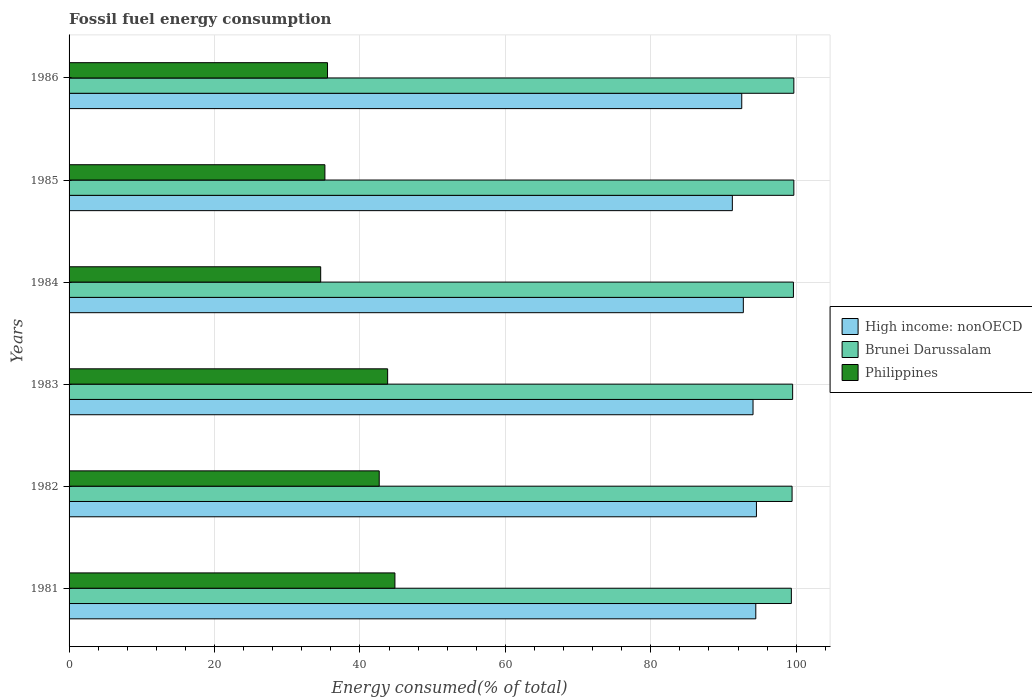How many different coloured bars are there?
Your response must be concise. 3. Are the number of bars per tick equal to the number of legend labels?
Your answer should be compact. Yes. How many bars are there on the 4th tick from the top?
Your answer should be compact. 3. In how many cases, is the number of bars for a given year not equal to the number of legend labels?
Provide a succinct answer. 0. What is the percentage of energy consumed in High income: nonOECD in 1983?
Ensure brevity in your answer.  94.06. Across all years, what is the maximum percentage of energy consumed in High income: nonOECD?
Give a very brief answer. 94.53. Across all years, what is the minimum percentage of energy consumed in Philippines?
Your answer should be compact. 34.6. In which year was the percentage of energy consumed in Brunei Darussalam minimum?
Your answer should be very brief. 1981. What is the total percentage of energy consumed in Philippines in the graph?
Offer a terse response. 236.6. What is the difference between the percentage of energy consumed in Philippines in 1981 and that in 1984?
Provide a succinct answer. 10.21. What is the difference between the percentage of energy consumed in Brunei Darussalam in 1985 and the percentage of energy consumed in Philippines in 1982?
Keep it short and to the point. 57.02. What is the average percentage of energy consumed in Brunei Darussalam per year?
Your answer should be very brief. 99.54. In the year 1983, what is the difference between the percentage of energy consumed in Philippines and percentage of energy consumed in Brunei Darussalam?
Offer a terse response. -55.7. In how many years, is the percentage of energy consumed in High income: nonOECD greater than 28 %?
Ensure brevity in your answer.  6. What is the ratio of the percentage of energy consumed in High income: nonOECD in 1982 to that in 1985?
Ensure brevity in your answer.  1.04. Is the percentage of energy consumed in Brunei Darussalam in 1981 less than that in 1984?
Make the answer very short. Yes. Is the difference between the percentage of energy consumed in Philippines in 1981 and 1984 greater than the difference between the percentage of energy consumed in Brunei Darussalam in 1981 and 1984?
Provide a short and direct response. Yes. What is the difference between the highest and the second highest percentage of energy consumed in Brunei Darussalam?
Keep it short and to the point. 0. What is the difference between the highest and the lowest percentage of energy consumed in High income: nonOECD?
Offer a terse response. 3.31. Is the sum of the percentage of energy consumed in High income: nonOECD in 1981 and 1982 greater than the maximum percentage of energy consumed in Philippines across all years?
Your answer should be compact. Yes. What does the 3rd bar from the top in 1984 represents?
Your response must be concise. High income: nonOECD. What does the 1st bar from the bottom in 1985 represents?
Offer a very short reply. High income: nonOECD. Are all the bars in the graph horizontal?
Your answer should be very brief. Yes. How many years are there in the graph?
Your answer should be compact. 6. What is the difference between two consecutive major ticks on the X-axis?
Offer a terse response. 20. Are the values on the major ticks of X-axis written in scientific E-notation?
Make the answer very short. No. Does the graph contain grids?
Provide a succinct answer. Yes. Where does the legend appear in the graph?
Your answer should be compact. Center right. How many legend labels are there?
Offer a very short reply. 3. How are the legend labels stacked?
Give a very brief answer. Vertical. What is the title of the graph?
Provide a succinct answer. Fossil fuel energy consumption. What is the label or title of the X-axis?
Offer a terse response. Energy consumed(% of total). What is the label or title of the Y-axis?
Offer a terse response. Years. What is the Energy consumed(% of total) in High income: nonOECD in 1981?
Provide a succinct answer. 94.44. What is the Energy consumed(% of total) in Brunei Darussalam in 1981?
Make the answer very short. 99.33. What is the Energy consumed(% of total) in Philippines in 1981?
Provide a succinct answer. 44.81. What is the Energy consumed(% of total) of High income: nonOECD in 1982?
Your response must be concise. 94.53. What is the Energy consumed(% of total) in Brunei Darussalam in 1982?
Keep it short and to the point. 99.43. What is the Energy consumed(% of total) of Philippines in 1982?
Provide a short and direct response. 42.65. What is the Energy consumed(% of total) of High income: nonOECD in 1983?
Provide a succinct answer. 94.06. What is the Energy consumed(% of total) in Brunei Darussalam in 1983?
Provide a short and direct response. 99.51. What is the Energy consumed(% of total) in Philippines in 1983?
Offer a terse response. 43.81. What is the Energy consumed(% of total) of High income: nonOECD in 1984?
Offer a terse response. 92.73. What is the Energy consumed(% of total) in Brunei Darussalam in 1984?
Ensure brevity in your answer.  99.62. What is the Energy consumed(% of total) of Philippines in 1984?
Give a very brief answer. 34.6. What is the Energy consumed(% of total) of High income: nonOECD in 1985?
Make the answer very short. 91.21. What is the Energy consumed(% of total) of Brunei Darussalam in 1985?
Offer a very short reply. 99.67. What is the Energy consumed(% of total) in Philippines in 1985?
Give a very brief answer. 35.18. What is the Energy consumed(% of total) in High income: nonOECD in 1986?
Your answer should be compact. 92.51. What is the Energy consumed(% of total) of Brunei Darussalam in 1986?
Provide a succinct answer. 99.67. What is the Energy consumed(% of total) in Philippines in 1986?
Your answer should be compact. 35.54. Across all years, what is the maximum Energy consumed(% of total) of High income: nonOECD?
Your response must be concise. 94.53. Across all years, what is the maximum Energy consumed(% of total) in Brunei Darussalam?
Provide a succinct answer. 99.67. Across all years, what is the maximum Energy consumed(% of total) of Philippines?
Your answer should be compact. 44.81. Across all years, what is the minimum Energy consumed(% of total) of High income: nonOECD?
Keep it short and to the point. 91.21. Across all years, what is the minimum Energy consumed(% of total) in Brunei Darussalam?
Provide a short and direct response. 99.33. Across all years, what is the minimum Energy consumed(% of total) in Philippines?
Make the answer very short. 34.6. What is the total Energy consumed(% of total) in High income: nonOECD in the graph?
Offer a terse response. 559.48. What is the total Energy consumed(% of total) in Brunei Darussalam in the graph?
Keep it short and to the point. 597.23. What is the total Energy consumed(% of total) in Philippines in the graph?
Ensure brevity in your answer.  236.6. What is the difference between the Energy consumed(% of total) in High income: nonOECD in 1981 and that in 1982?
Give a very brief answer. -0.09. What is the difference between the Energy consumed(% of total) of Brunei Darussalam in 1981 and that in 1982?
Make the answer very short. -0.1. What is the difference between the Energy consumed(% of total) in Philippines in 1981 and that in 1982?
Offer a terse response. 2.16. What is the difference between the Energy consumed(% of total) of High income: nonOECD in 1981 and that in 1983?
Give a very brief answer. 0.38. What is the difference between the Energy consumed(% of total) in Brunei Darussalam in 1981 and that in 1983?
Provide a succinct answer. -0.18. What is the difference between the Energy consumed(% of total) in High income: nonOECD in 1981 and that in 1984?
Ensure brevity in your answer.  1.71. What is the difference between the Energy consumed(% of total) in Brunei Darussalam in 1981 and that in 1984?
Your answer should be compact. -0.28. What is the difference between the Energy consumed(% of total) of Philippines in 1981 and that in 1984?
Your answer should be compact. 10.21. What is the difference between the Energy consumed(% of total) in High income: nonOECD in 1981 and that in 1985?
Make the answer very short. 3.22. What is the difference between the Energy consumed(% of total) in Brunei Darussalam in 1981 and that in 1985?
Offer a terse response. -0.34. What is the difference between the Energy consumed(% of total) in Philippines in 1981 and that in 1985?
Keep it short and to the point. 9.63. What is the difference between the Energy consumed(% of total) of High income: nonOECD in 1981 and that in 1986?
Offer a terse response. 1.93. What is the difference between the Energy consumed(% of total) in Brunei Darussalam in 1981 and that in 1986?
Keep it short and to the point. -0.34. What is the difference between the Energy consumed(% of total) in Philippines in 1981 and that in 1986?
Offer a very short reply. 9.27. What is the difference between the Energy consumed(% of total) of High income: nonOECD in 1982 and that in 1983?
Your answer should be very brief. 0.47. What is the difference between the Energy consumed(% of total) of Brunei Darussalam in 1982 and that in 1983?
Your answer should be very brief. -0.08. What is the difference between the Energy consumed(% of total) of Philippines in 1982 and that in 1983?
Offer a very short reply. -1.16. What is the difference between the Energy consumed(% of total) in High income: nonOECD in 1982 and that in 1984?
Your answer should be very brief. 1.8. What is the difference between the Energy consumed(% of total) of Brunei Darussalam in 1982 and that in 1984?
Give a very brief answer. -0.19. What is the difference between the Energy consumed(% of total) in Philippines in 1982 and that in 1984?
Make the answer very short. 8.05. What is the difference between the Energy consumed(% of total) of High income: nonOECD in 1982 and that in 1985?
Offer a very short reply. 3.31. What is the difference between the Energy consumed(% of total) of Brunei Darussalam in 1982 and that in 1985?
Provide a succinct answer. -0.24. What is the difference between the Energy consumed(% of total) of Philippines in 1982 and that in 1985?
Offer a very short reply. 7.47. What is the difference between the Energy consumed(% of total) in High income: nonOECD in 1982 and that in 1986?
Your answer should be very brief. 2.02. What is the difference between the Energy consumed(% of total) in Brunei Darussalam in 1982 and that in 1986?
Offer a terse response. -0.24. What is the difference between the Energy consumed(% of total) of Philippines in 1982 and that in 1986?
Give a very brief answer. 7.11. What is the difference between the Energy consumed(% of total) of High income: nonOECD in 1983 and that in 1984?
Your answer should be very brief. 1.34. What is the difference between the Energy consumed(% of total) in Brunei Darussalam in 1983 and that in 1984?
Ensure brevity in your answer.  -0.11. What is the difference between the Energy consumed(% of total) in Philippines in 1983 and that in 1984?
Ensure brevity in your answer.  9.21. What is the difference between the Energy consumed(% of total) of High income: nonOECD in 1983 and that in 1985?
Offer a very short reply. 2.85. What is the difference between the Energy consumed(% of total) of Brunei Darussalam in 1983 and that in 1985?
Keep it short and to the point. -0.17. What is the difference between the Energy consumed(% of total) in Philippines in 1983 and that in 1985?
Your answer should be compact. 8.63. What is the difference between the Energy consumed(% of total) in High income: nonOECD in 1983 and that in 1986?
Provide a succinct answer. 1.55. What is the difference between the Energy consumed(% of total) of Brunei Darussalam in 1983 and that in 1986?
Give a very brief answer. -0.17. What is the difference between the Energy consumed(% of total) in Philippines in 1983 and that in 1986?
Ensure brevity in your answer.  8.27. What is the difference between the Energy consumed(% of total) in High income: nonOECD in 1984 and that in 1985?
Give a very brief answer. 1.51. What is the difference between the Energy consumed(% of total) of Brunei Darussalam in 1984 and that in 1985?
Your answer should be compact. -0.06. What is the difference between the Energy consumed(% of total) in Philippines in 1984 and that in 1985?
Keep it short and to the point. -0.58. What is the difference between the Energy consumed(% of total) in High income: nonOECD in 1984 and that in 1986?
Your answer should be compact. 0.22. What is the difference between the Energy consumed(% of total) of Brunei Darussalam in 1984 and that in 1986?
Your response must be concise. -0.06. What is the difference between the Energy consumed(% of total) in Philippines in 1984 and that in 1986?
Make the answer very short. -0.94. What is the difference between the Energy consumed(% of total) in High income: nonOECD in 1985 and that in 1986?
Provide a short and direct response. -1.29. What is the difference between the Energy consumed(% of total) in Brunei Darussalam in 1985 and that in 1986?
Make the answer very short. -0. What is the difference between the Energy consumed(% of total) in Philippines in 1985 and that in 1986?
Your response must be concise. -0.36. What is the difference between the Energy consumed(% of total) of High income: nonOECD in 1981 and the Energy consumed(% of total) of Brunei Darussalam in 1982?
Offer a terse response. -4.99. What is the difference between the Energy consumed(% of total) in High income: nonOECD in 1981 and the Energy consumed(% of total) in Philippines in 1982?
Your answer should be compact. 51.79. What is the difference between the Energy consumed(% of total) in Brunei Darussalam in 1981 and the Energy consumed(% of total) in Philippines in 1982?
Keep it short and to the point. 56.68. What is the difference between the Energy consumed(% of total) of High income: nonOECD in 1981 and the Energy consumed(% of total) of Brunei Darussalam in 1983?
Offer a terse response. -5.07. What is the difference between the Energy consumed(% of total) in High income: nonOECD in 1981 and the Energy consumed(% of total) in Philippines in 1983?
Your response must be concise. 50.63. What is the difference between the Energy consumed(% of total) of Brunei Darussalam in 1981 and the Energy consumed(% of total) of Philippines in 1983?
Your response must be concise. 55.52. What is the difference between the Energy consumed(% of total) in High income: nonOECD in 1981 and the Energy consumed(% of total) in Brunei Darussalam in 1984?
Offer a very short reply. -5.18. What is the difference between the Energy consumed(% of total) in High income: nonOECD in 1981 and the Energy consumed(% of total) in Philippines in 1984?
Your answer should be very brief. 59.84. What is the difference between the Energy consumed(% of total) in Brunei Darussalam in 1981 and the Energy consumed(% of total) in Philippines in 1984?
Your answer should be compact. 64.73. What is the difference between the Energy consumed(% of total) in High income: nonOECD in 1981 and the Energy consumed(% of total) in Brunei Darussalam in 1985?
Ensure brevity in your answer.  -5.23. What is the difference between the Energy consumed(% of total) in High income: nonOECD in 1981 and the Energy consumed(% of total) in Philippines in 1985?
Provide a short and direct response. 59.26. What is the difference between the Energy consumed(% of total) in Brunei Darussalam in 1981 and the Energy consumed(% of total) in Philippines in 1985?
Your answer should be very brief. 64.15. What is the difference between the Energy consumed(% of total) in High income: nonOECD in 1981 and the Energy consumed(% of total) in Brunei Darussalam in 1986?
Offer a very short reply. -5.23. What is the difference between the Energy consumed(% of total) of High income: nonOECD in 1981 and the Energy consumed(% of total) of Philippines in 1986?
Give a very brief answer. 58.9. What is the difference between the Energy consumed(% of total) of Brunei Darussalam in 1981 and the Energy consumed(% of total) of Philippines in 1986?
Offer a very short reply. 63.79. What is the difference between the Energy consumed(% of total) in High income: nonOECD in 1982 and the Energy consumed(% of total) in Brunei Darussalam in 1983?
Ensure brevity in your answer.  -4.98. What is the difference between the Energy consumed(% of total) in High income: nonOECD in 1982 and the Energy consumed(% of total) in Philippines in 1983?
Make the answer very short. 50.72. What is the difference between the Energy consumed(% of total) of Brunei Darussalam in 1982 and the Energy consumed(% of total) of Philippines in 1983?
Offer a terse response. 55.62. What is the difference between the Energy consumed(% of total) in High income: nonOECD in 1982 and the Energy consumed(% of total) in Brunei Darussalam in 1984?
Give a very brief answer. -5.09. What is the difference between the Energy consumed(% of total) in High income: nonOECD in 1982 and the Energy consumed(% of total) in Philippines in 1984?
Offer a very short reply. 59.93. What is the difference between the Energy consumed(% of total) of Brunei Darussalam in 1982 and the Energy consumed(% of total) of Philippines in 1984?
Your response must be concise. 64.83. What is the difference between the Energy consumed(% of total) of High income: nonOECD in 1982 and the Energy consumed(% of total) of Brunei Darussalam in 1985?
Offer a terse response. -5.14. What is the difference between the Energy consumed(% of total) in High income: nonOECD in 1982 and the Energy consumed(% of total) in Philippines in 1985?
Keep it short and to the point. 59.35. What is the difference between the Energy consumed(% of total) in Brunei Darussalam in 1982 and the Energy consumed(% of total) in Philippines in 1985?
Provide a short and direct response. 64.25. What is the difference between the Energy consumed(% of total) of High income: nonOECD in 1982 and the Energy consumed(% of total) of Brunei Darussalam in 1986?
Make the answer very short. -5.14. What is the difference between the Energy consumed(% of total) in High income: nonOECD in 1982 and the Energy consumed(% of total) in Philippines in 1986?
Provide a succinct answer. 58.99. What is the difference between the Energy consumed(% of total) of Brunei Darussalam in 1982 and the Energy consumed(% of total) of Philippines in 1986?
Offer a terse response. 63.89. What is the difference between the Energy consumed(% of total) in High income: nonOECD in 1983 and the Energy consumed(% of total) in Brunei Darussalam in 1984?
Offer a terse response. -5.55. What is the difference between the Energy consumed(% of total) of High income: nonOECD in 1983 and the Energy consumed(% of total) of Philippines in 1984?
Offer a very short reply. 59.46. What is the difference between the Energy consumed(% of total) of Brunei Darussalam in 1983 and the Energy consumed(% of total) of Philippines in 1984?
Give a very brief answer. 64.91. What is the difference between the Energy consumed(% of total) in High income: nonOECD in 1983 and the Energy consumed(% of total) in Brunei Darussalam in 1985?
Provide a short and direct response. -5.61. What is the difference between the Energy consumed(% of total) of High income: nonOECD in 1983 and the Energy consumed(% of total) of Philippines in 1985?
Your response must be concise. 58.88. What is the difference between the Energy consumed(% of total) of Brunei Darussalam in 1983 and the Energy consumed(% of total) of Philippines in 1985?
Offer a terse response. 64.33. What is the difference between the Energy consumed(% of total) of High income: nonOECD in 1983 and the Energy consumed(% of total) of Brunei Darussalam in 1986?
Your answer should be very brief. -5.61. What is the difference between the Energy consumed(% of total) of High income: nonOECD in 1983 and the Energy consumed(% of total) of Philippines in 1986?
Provide a succinct answer. 58.52. What is the difference between the Energy consumed(% of total) of Brunei Darussalam in 1983 and the Energy consumed(% of total) of Philippines in 1986?
Your answer should be very brief. 63.97. What is the difference between the Energy consumed(% of total) of High income: nonOECD in 1984 and the Energy consumed(% of total) of Brunei Darussalam in 1985?
Your response must be concise. -6.95. What is the difference between the Energy consumed(% of total) in High income: nonOECD in 1984 and the Energy consumed(% of total) in Philippines in 1985?
Your answer should be very brief. 57.54. What is the difference between the Energy consumed(% of total) in Brunei Darussalam in 1984 and the Energy consumed(% of total) in Philippines in 1985?
Your answer should be compact. 64.43. What is the difference between the Energy consumed(% of total) in High income: nonOECD in 1984 and the Energy consumed(% of total) in Brunei Darussalam in 1986?
Provide a short and direct response. -6.95. What is the difference between the Energy consumed(% of total) in High income: nonOECD in 1984 and the Energy consumed(% of total) in Philippines in 1986?
Offer a very short reply. 57.18. What is the difference between the Energy consumed(% of total) in Brunei Darussalam in 1984 and the Energy consumed(% of total) in Philippines in 1986?
Offer a very short reply. 64.07. What is the difference between the Energy consumed(% of total) of High income: nonOECD in 1985 and the Energy consumed(% of total) of Brunei Darussalam in 1986?
Keep it short and to the point. -8.46. What is the difference between the Energy consumed(% of total) in High income: nonOECD in 1985 and the Energy consumed(% of total) in Philippines in 1986?
Offer a very short reply. 55.67. What is the difference between the Energy consumed(% of total) of Brunei Darussalam in 1985 and the Energy consumed(% of total) of Philippines in 1986?
Keep it short and to the point. 64.13. What is the average Energy consumed(% of total) of High income: nonOECD per year?
Provide a succinct answer. 93.25. What is the average Energy consumed(% of total) of Brunei Darussalam per year?
Provide a succinct answer. 99.54. What is the average Energy consumed(% of total) of Philippines per year?
Provide a short and direct response. 39.43. In the year 1981, what is the difference between the Energy consumed(% of total) of High income: nonOECD and Energy consumed(% of total) of Brunei Darussalam?
Keep it short and to the point. -4.89. In the year 1981, what is the difference between the Energy consumed(% of total) of High income: nonOECD and Energy consumed(% of total) of Philippines?
Your answer should be very brief. 49.63. In the year 1981, what is the difference between the Energy consumed(% of total) of Brunei Darussalam and Energy consumed(% of total) of Philippines?
Offer a terse response. 54.52. In the year 1982, what is the difference between the Energy consumed(% of total) of High income: nonOECD and Energy consumed(% of total) of Brunei Darussalam?
Provide a short and direct response. -4.9. In the year 1982, what is the difference between the Energy consumed(% of total) of High income: nonOECD and Energy consumed(% of total) of Philippines?
Ensure brevity in your answer.  51.88. In the year 1982, what is the difference between the Energy consumed(% of total) of Brunei Darussalam and Energy consumed(% of total) of Philippines?
Your answer should be compact. 56.78. In the year 1983, what is the difference between the Energy consumed(% of total) in High income: nonOECD and Energy consumed(% of total) in Brunei Darussalam?
Give a very brief answer. -5.45. In the year 1983, what is the difference between the Energy consumed(% of total) in High income: nonOECD and Energy consumed(% of total) in Philippines?
Make the answer very short. 50.25. In the year 1983, what is the difference between the Energy consumed(% of total) of Brunei Darussalam and Energy consumed(% of total) of Philippines?
Provide a short and direct response. 55.7. In the year 1984, what is the difference between the Energy consumed(% of total) in High income: nonOECD and Energy consumed(% of total) in Brunei Darussalam?
Provide a succinct answer. -6.89. In the year 1984, what is the difference between the Energy consumed(% of total) of High income: nonOECD and Energy consumed(% of total) of Philippines?
Provide a succinct answer. 58.12. In the year 1984, what is the difference between the Energy consumed(% of total) of Brunei Darussalam and Energy consumed(% of total) of Philippines?
Your answer should be very brief. 65.01. In the year 1985, what is the difference between the Energy consumed(% of total) in High income: nonOECD and Energy consumed(% of total) in Brunei Darussalam?
Offer a terse response. -8.46. In the year 1985, what is the difference between the Energy consumed(% of total) in High income: nonOECD and Energy consumed(% of total) in Philippines?
Your answer should be compact. 56.03. In the year 1985, what is the difference between the Energy consumed(% of total) of Brunei Darussalam and Energy consumed(% of total) of Philippines?
Offer a very short reply. 64.49. In the year 1986, what is the difference between the Energy consumed(% of total) of High income: nonOECD and Energy consumed(% of total) of Brunei Darussalam?
Provide a succinct answer. -7.16. In the year 1986, what is the difference between the Energy consumed(% of total) in High income: nonOECD and Energy consumed(% of total) in Philippines?
Your answer should be very brief. 56.97. In the year 1986, what is the difference between the Energy consumed(% of total) of Brunei Darussalam and Energy consumed(% of total) of Philippines?
Give a very brief answer. 64.13. What is the ratio of the Energy consumed(% of total) in Philippines in 1981 to that in 1982?
Keep it short and to the point. 1.05. What is the ratio of the Energy consumed(% of total) in High income: nonOECD in 1981 to that in 1983?
Provide a short and direct response. 1. What is the ratio of the Energy consumed(% of total) in Brunei Darussalam in 1981 to that in 1983?
Your answer should be very brief. 1. What is the ratio of the Energy consumed(% of total) in Philippines in 1981 to that in 1983?
Ensure brevity in your answer.  1.02. What is the ratio of the Energy consumed(% of total) in High income: nonOECD in 1981 to that in 1984?
Your answer should be compact. 1.02. What is the ratio of the Energy consumed(% of total) of Philippines in 1981 to that in 1984?
Offer a very short reply. 1.29. What is the ratio of the Energy consumed(% of total) of High income: nonOECD in 1981 to that in 1985?
Your response must be concise. 1.04. What is the ratio of the Energy consumed(% of total) of Brunei Darussalam in 1981 to that in 1985?
Your answer should be very brief. 1. What is the ratio of the Energy consumed(% of total) in Philippines in 1981 to that in 1985?
Give a very brief answer. 1.27. What is the ratio of the Energy consumed(% of total) of High income: nonOECD in 1981 to that in 1986?
Your answer should be compact. 1.02. What is the ratio of the Energy consumed(% of total) in Brunei Darussalam in 1981 to that in 1986?
Offer a very short reply. 1. What is the ratio of the Energy consumed(% of total) of Philippines in 1981 to that in 1986?
Provide a succinct answer. 1.26. What is the ratio of the Energy consumed(% of total) in High income: nonOECD in 1982 to that in 1983?
Give a very brief answer. 1. What is the ratio of the Energy consumed(% of total) of Philippines in 1982 to that in 1983?
Your answer should be compact. 0.97. What is the ratio of the Energy consumed(% of total) of High income: nonOECD in 1982 to that in 1984?
Your response must be concise. 1.02. What is the ratio of the Energy consumed(% of total) of Philippines in 1982 to that in 1984?
Your answer should be very brief. 1.23. What is the ratio of the Energy consumed(% of total) in High income: nonOECD in 1982 to that in 1985?
Offer a very short reply. 1.04. What is the ratio of the Energy consumed(% of total) in Philippines in 1982 to that in 1985?
Provide a succinct answer. 1.21. What is the ratio of the Energy consumed(% of total) in High income: nonOECD in 1982 to that in 1986?
Provide a succinct answer. 1.02. What is the ratio of the Energy consumed(% of total) of Brunei Darussalam in 1982 to that in 1986?
Your response must be concise. 1. What is the ratio of the Energy consumed(% of total) of Philippines in 1982 to that in 1986?
Offer a very short reply. 1.2. What is the ratio of the Energy consumed(% of total) of High income: nonOECD in 1983 to that in 1984?
Give a very brief answer. 1.01. What is the ratio of the Energy consumed(% of total) in Philippines in 1983 to that in 1984?
Your answer should be compact. 1.27. What is the ratio of the Energy consumed(% of total) in High income: nonOECD in 1983 to that in 1985?
Your answer should be very brief. 1.03. What is the ratio of the Energy consumed(% of total) in Brunei Darussalam in 1983 to that in 1985?
Offer a very short reply. 1. What is the ratio of the Energy consumed(% of total) in Philippines in 1983 to that in 1985?
Ensure brevity in your answer.  1.25. What is the ratio of the Energy consumed(% of total) of High income: nonOECD in 1983 to that in 1986?
Provide a succinct answer. 1.02. What is the ratio of the Energy consumed(% of total) in Brunei Darussalam in 1983 to that in 1986?
Give a very brief answer. 1. What is the ratio of the Energy consumed(% of total) of Philippines in 1983 to that in 1986?
Ensure brevity in your answer.  1.23. What is the ratio of the Energy consumed(% of total) in High income: nonOECD in 1984 to that in 1985?
Make the answer very short. 1.02. What is the ratio of the Energy consumed(% of total) of Philippines in 1984 to that in 1985?
Offer a very short reply. 0.98. What is the ratio of the Energy consumed(% of total) in High income: nonOECD in 1984 to that in 1986?
Offer a very short reply. 1. What is the ratio of the Energy consumed(% of total) in Philippines in 1984 to that in 1986?
Give a very brief answer. 0.97. What is the ratio of the Energy consumed(% of total) in High income: nonOECD in 1985 to that in 1986?
Provide a short and direct response. 0.99. What is the ratio of the Energy consumed(% of total) of Brunei Darussalam in 1985 to that in 1986?
Give a very brief answer. 1. What is the difference between the highest and the second highest Energy consumed(% of total) of High income: nonOECD?
Ensure brevity in your answer.  0.09. What is the difference between the highest and the second highest Energy consumed(% of total) in Brunei Darussalam?
Your answer should be very brief. 0. What is the difference between the highest and the lowest Energy consumed(% of total) in High income: nonOECD?
Provide a short and direct response. 3.31. What is the difference between the highest and the lowest Energy consumed(% of total) of Brunei Darussalam?
Offer a very short reply. 0.34. What is the difference between the highest and the lowest Energy consumed(% of total) of Philippines?
Your answer should be very brief. 10.21. 